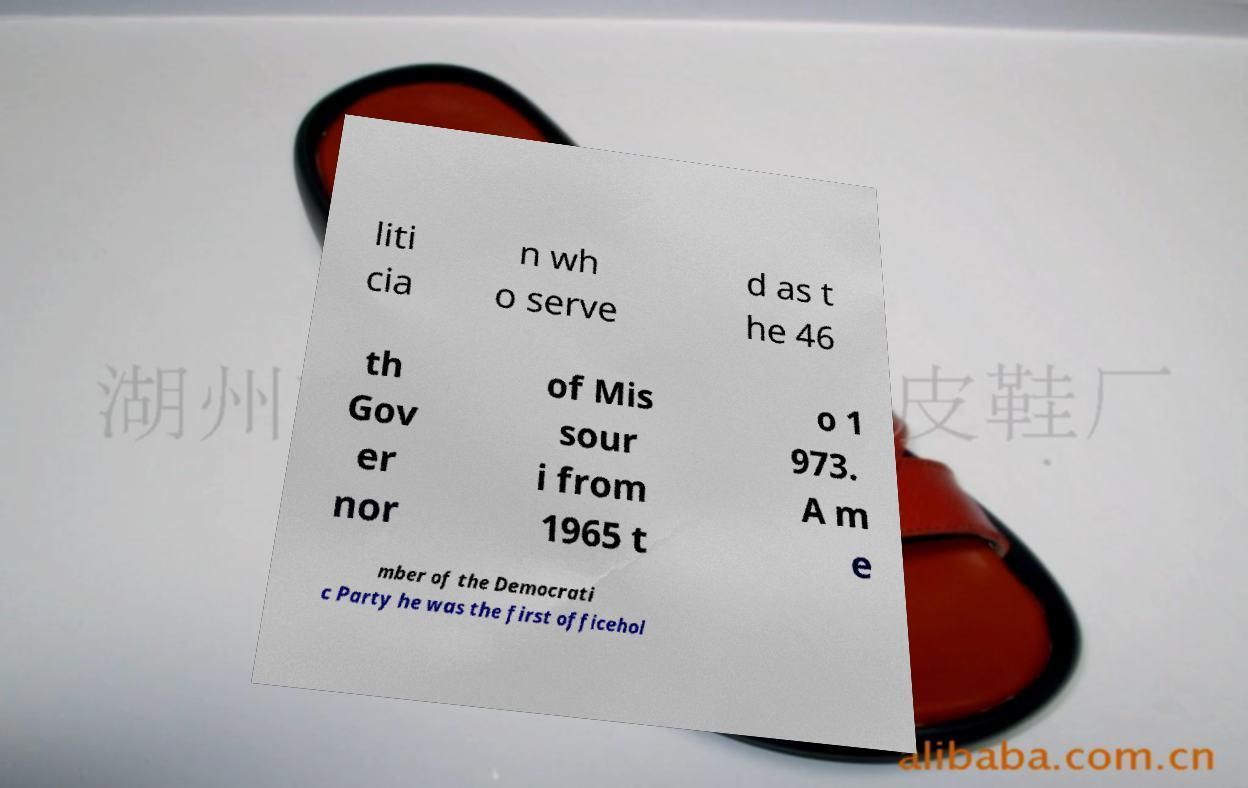What messages or text are displayed in this image? I need them in a readable, typed format. liti cia n wh o serve d as t he 46 th Gov er nor of Mis sour i from 1965 t o 1 973. A m e mber of the Democrati c Party he was the first officehol 